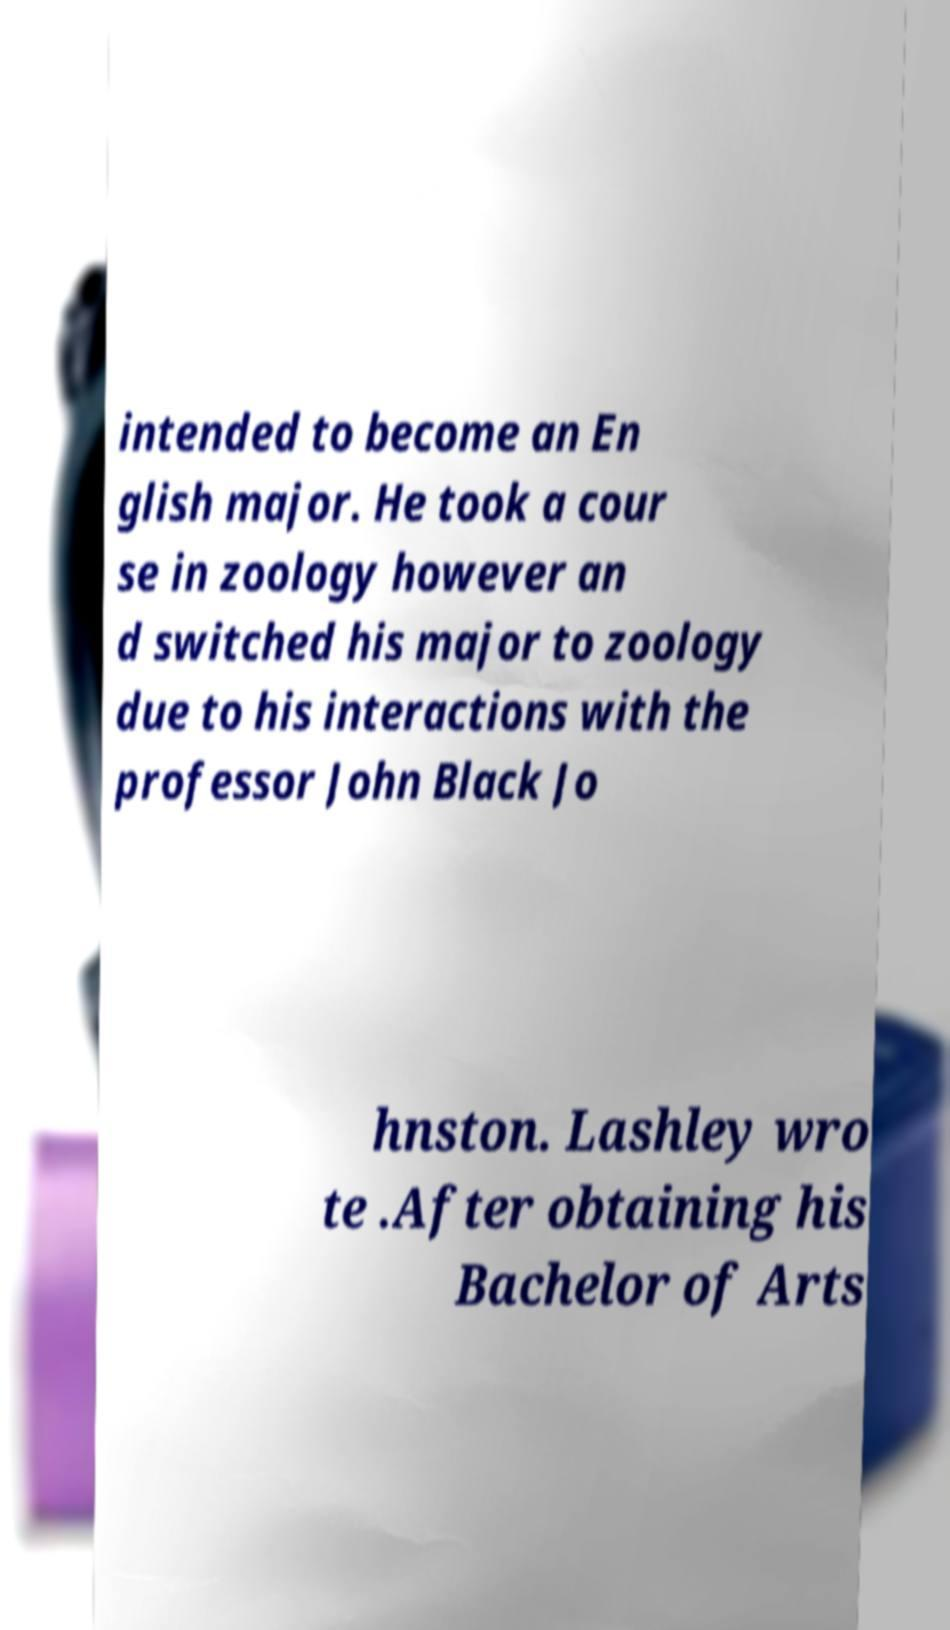Can you accurately transcribe the text from the provided image for me? intended to become an En glish major. He took a cour se in zoology however an d switched his major to zoology due to his interactions with the professor John Black Jo hnston. Lashley wro te .After obtaining his Bachelor of Arts 